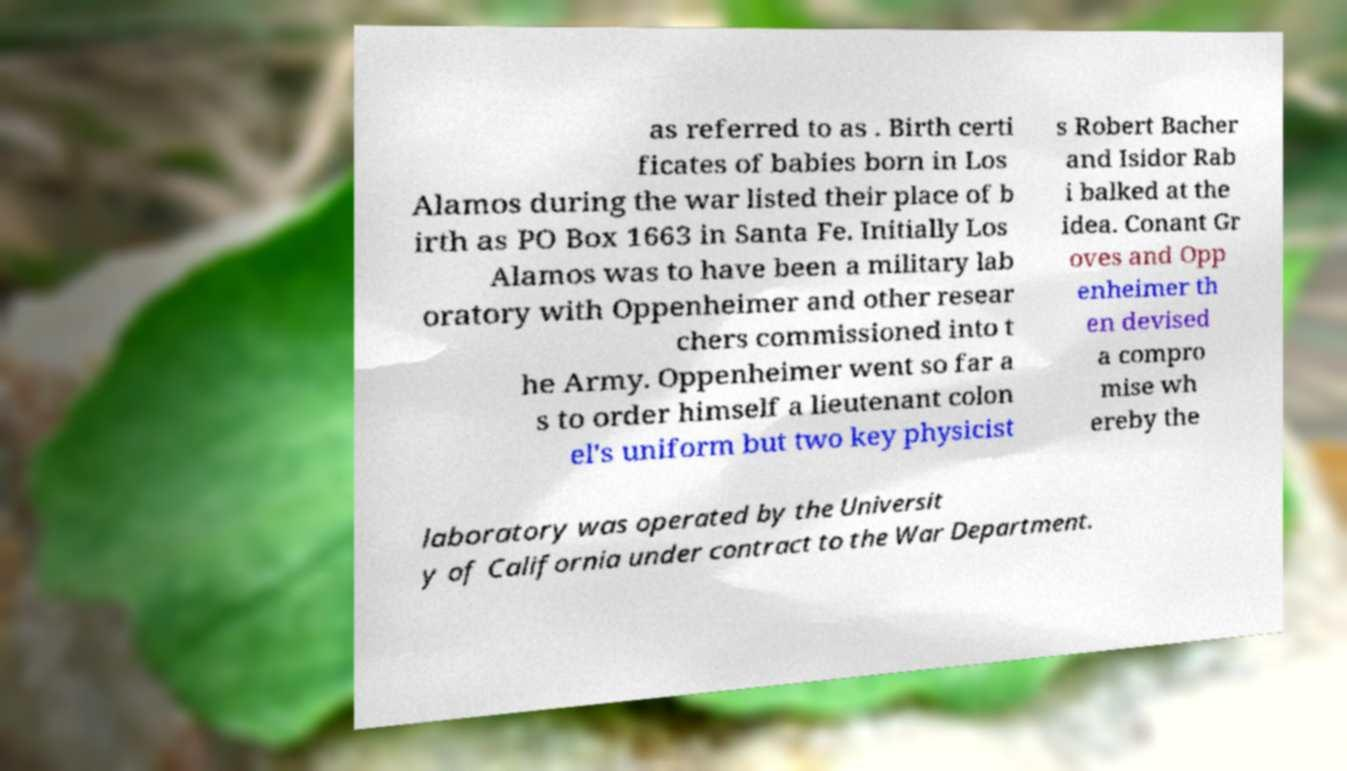Can you read and provide the text displayed in the image?This photo seems to have some interesting text. Can you extract and type it out for me? as referred to as . Birth certi ficates of babies born in Los Alamos during the war listed their place of b irth as PO Box 1663 in Santa Fe. Initially Los Alamos was to have been a military lab oratory with Oppenheimer and other resear chers commissioned into t he Army. Oppenheimer went so far a s to order himself a lieutenant colon el's uniform but two key physicist s Robert Bacher and Isidor Rab i balked at the idea. Conant Gr oves and Opp enheimer th en devised a compro mise wh ereby the laboratory was operated by the Universit y of California under contract to the War Department. 